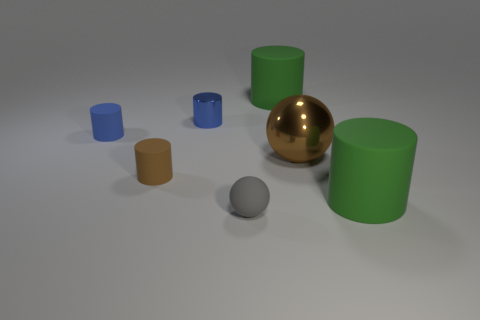Subtract 2 cylinders. How many cylinders are left? 3 Subtract all brown cylinders. How many cylinders are left? 4 Subtract all yellow cylinders. Subtract all gray blocks. How many cylinders are left? 5 Add 3 balls. How many objects exist? 10 Subtract all cylinders. How many objects are left? 2 Subtract 1 green cylinders. How many objects are left? 6 Subtract all tiny gray cylinders. Subtract all green rubber objects. How many objects are left? 5 Add 6 large brown shiny things. How many large brown shiny things are left? 7 Add 4 tiny cyan cylinders. How many tiny cyan cylinders exist? 4 